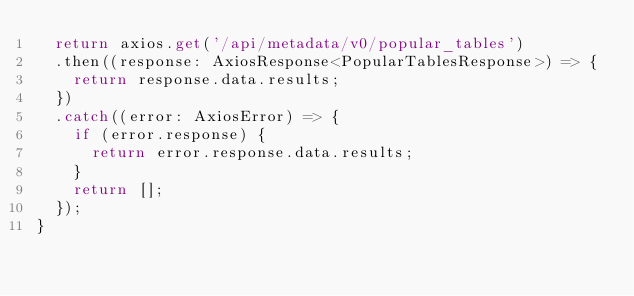Convert code to text. <code><loc_0><loc_0><loc_500><loc_500><_TypeScript_>  return axios.get('/api/metadata/v0/popular_tables')
  .then((response: AxiosResponse<PopularTablesResponse>) => {
    return response.data.results;
  })
  .catch((error: AxiosError) => {
    if (error.response) {
      return error.response.data.results;
    }
    return [];
  });
}
</code> 